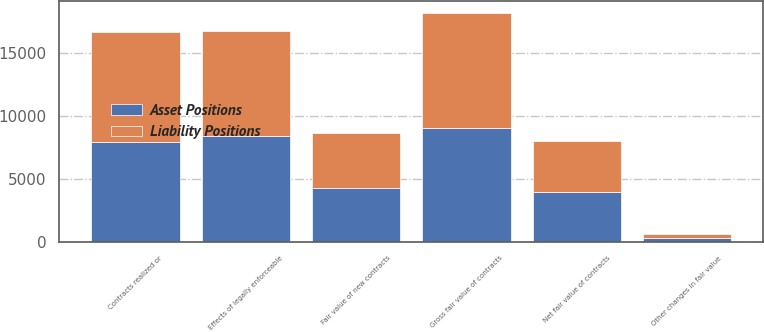Convert chart to OTSL. <chart><loc_0><loc_0><loc_500><loc_500><stacked_bar_chart><ecel><fcel>Net fair value of contracts<fcel>Effects of legally enforceable<fcel>Gross fair value of contracts<fcel>Contracts realized or<fcel>Fair value of new contracts<fcel>Other changes in fair value<nl><fcel>Liability Positions<fcel>4041<fcel>8399<fcel>9151<fcel>8755<fcel>4364<fcel>365<nl><fcel>Asset Positions<fcel>3977<fcel>8399<fcel>9087<fcel>7926<fcel>4294<fcel>265<nl></chart> 